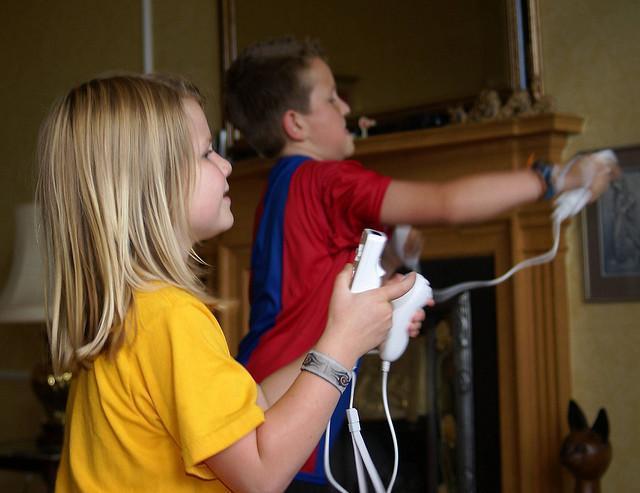How many people can you see?
Give a very brief answer. 2. 